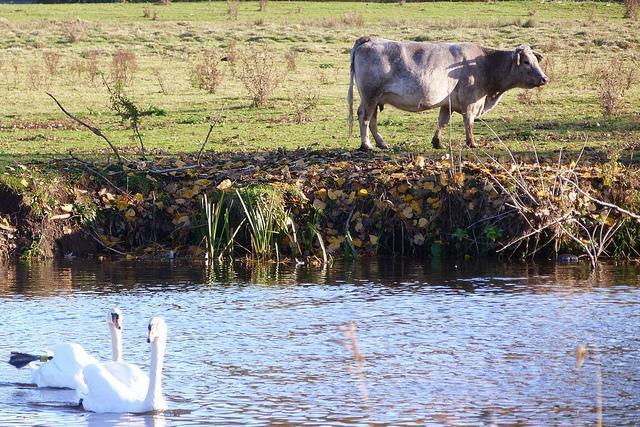How many swans are pictured?
Give a very brief answer. 2. How many ducks are clearly seen?
Give a very brief answer. 2. How many birds are there?
Give a very brief answer. 2. 